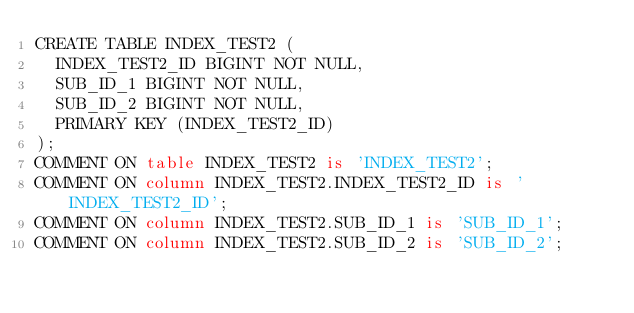Convert code to text. <code><loc_0><loc_0><loc_500><loc_500><_SQL_>CREATE TABLE INDEX_TEST2 (
  INDEX_TEST2_ID BIGINT NOT NULL,
  SUB_ID_1 BIGINT NOT NULL,
  SUB_ID_2 BIGINT NOT NULL,
  PRIMARY KEY (INDEX_TEST2_ID)
);
COMMENT ON table INDEX_TEST2 is 'INDEX_TEST2';
COMMENT ON column INDEX_TEST2.INDEX_TEST2_ID is 'INDEX_TEST2_ID';
COMMENT ON column INDEX_TEST2.SUB_ID_1 is 'SUB_ID_1';
COMMENT ON column INDEX_TEST2.SUB_ID_2 is 'SUB_ID_2';
</code> 